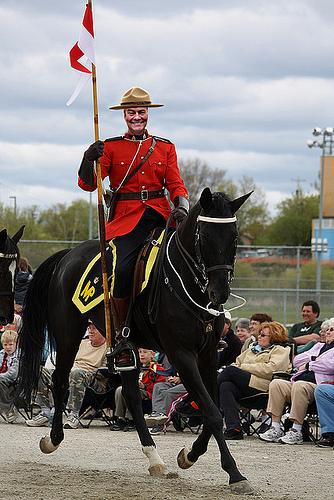Estimate the total number of people depicted in the image description and list their possible activities. There are at least four people: an officer riding the horse, a woman sitting on a chair, a man holding a flag, and a person or people sitting and watching. Describe the overall sentiment or mood the image description evokes. The image evokes a sense of action and outdoor gathering, with a focus on the black horse and various people engaging in different activities. Identify the type of fence mentioned in the image description and any nearby objects. A chain-link fence is mentioned, with gray dirt and rocks nearby. What is the lady wearing in the image and what is the color of her hair? The lady is wearing tan slacks, possibly a tan jacket, white sneakers, and dark sunglasses. She has red hair. Name one object in the picture related to weather and describe its characteristics. There are white and gray clouds against a blue sky, which indicates overcast weather conditions. List the main objects and their corresponding colors visible in the picture. Black horse, red and white flag, man with a red jacket, lady with tan slacks, gray dirt and rocks, white and gray clouds, blue sky. Identify the color and type of the horse depicted in the image. The horse in the image is a black dark-haired horse trotting and being ridden by an officer. In a short sentence, describe the colors and condition of the flag in the image. The flag is red and white, and it looks like it is being carried or held up by a man. Briefly describe one man's attire, including the type and color of his shirt and whether he is wearing a hat or not. A smiling man is wearing a green shirt and tan hat. Mention how many people are interacting with the horse and what they are wearing. One man, an officer wearing a red jacket, is interacting with the horse by riding it. Identify the interaction between the woman and her footwear. woman wearing white sneakers Describe the state of the lights outside the building. the lights are off Give a detailed description of the horse's appearance. black horse with long black tail and white bridle Describe the horse's action in the scene. trotting What is the woman with the tan jacket wearing on her feet? white sneakers Explain the sky's appearance and colors. white and gray clouds against blue sky Is there a dog in the image? There is a "black horse", "black horse is trotting", and "dark haired horse", but no mention of any dogs in the image. Choose the correct description of the scene: a) black horse being ridden by a lady, b) man riding a brown horse, c) black horse being ridden by an officer. c) black horse being ridden by an officer Identify the color of the man's jacket and describe an accessory in the jacket. red jacket with black belt Tell me the colors of the flag and its elements. red and white What action are the people in the scene performing? watching and sitting Point out the person wearing dark sunglasses. lady wearing dark sunglasses What type of pants is the man wearing while riding the horse? camouflage pants Does the man have a green hat? There is a "man wearing a tan hat", "man wearing a hat", and "he is wearing a hat," but no mention of a man with a green hat. What is the man who is carrying a flag wearing on his head? a tan hat Is the woman wearing a blue jacket? There is a "woman wearing tan jacket" and "she is wearing a pink jacket," but no mention of a woman wearing a blue jacket. Provide a vivid caption for the scene involving a man and a horse. black horse being ridden by officer wearing red jacket Express the weather condition in the image. overcast sky Tell me about the appearance of the man who is wearing the red shirt. he is wearing a hat and carrying a flag Are there any bicycles in the image? No mention of bicycles or any related objects in the image. Are there yellow flags in the image? There are a few occurrences of "red and white flag", but no mention of yellow flags. What color is the horse? black What are the people doing in the image? a) dancing, b) sitting, c) running b) sitting Is the horse wearing a blue saddle? No mention of any saddles in the image, let alone a blue one. What is the man wearing while riding the black horse? a red jacket 